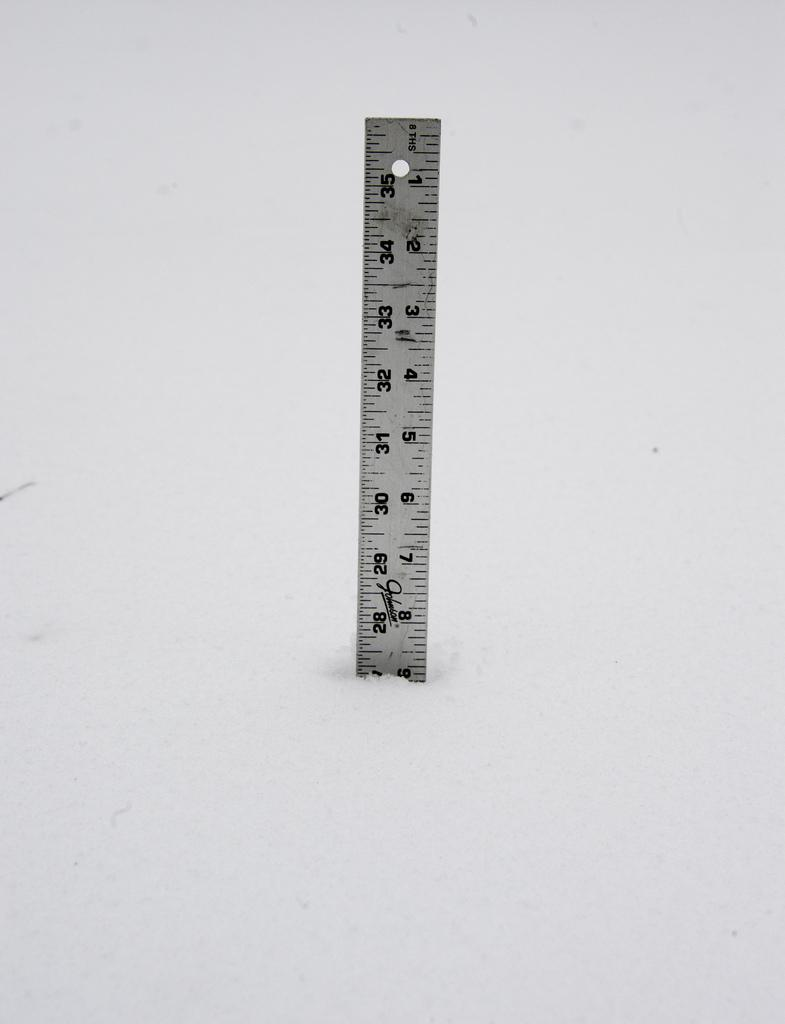<image>
Write a terse but informative summary of the picture. Partial ruler showing from 1 to 9 inches and looks like it has ripped end. 